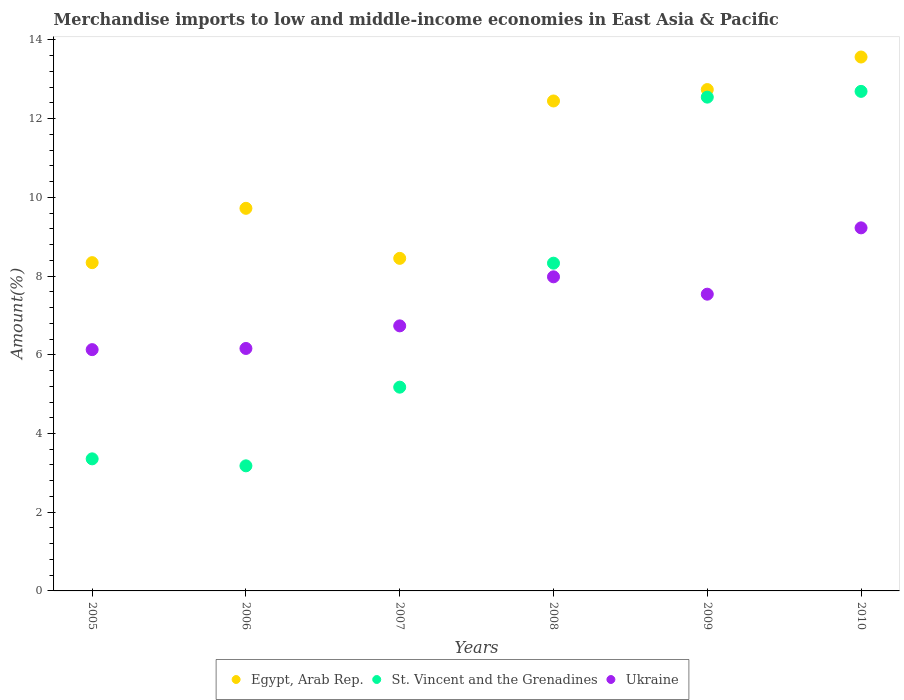How many different coloured dotlines are there?
Your response must be concise. 3. Is the number of dotlines equal to the number of legend labels?
Give a very brief answer. Yes. What is the percentage of amount earned from merchandise imports in Egypt, Arab Rep. in 2005?
Your answer should be very brief. 8.34. Across all years, what is the maximum percentage of amount earned from merchandise imports in Egypt, Arab Rep.?
Offer a terse response. 13.57. Across all years, what is the minimum percentage of amount earned from merchandise imports in Egypt, Arab Rep.?
Provide a short and direct response. 8.34. In which year was the percentage of amount earned from merchandise imports in Egypt, Arab Rep. maximum?
Keep it short and to the point. 2010. What is the total percentage of amount earned from merchandise imports in Egypt, Arab Rep. in the graph?
Your answer should be compact. 65.26. What is the difference between the percentage of amount earned from merchandise imports in Ukraine in 2005 and that in 2006?
Your answer should be very brief. -0.03. What is the difference between the percentage of amount earned from merchandise imports in Egypt, Arab Rep. in 2005 and the percentage of amount earned from merchandise imports in Ukraine in 2008?
Provide a succinct answer. 0.36. What is the average percentage of amount earned from merchandise imports in St. Vincent and the Grenadines per year?
Offer a very short reply. 7.55. In the year 2006, what is the difference between the percentage of amount earned from merchandise imports in Egypt, Arab Rep. and percentage of amount earned from merchandise imports in St. Vincent and the Grenadines?
Offer a terse response. 6.54. What is the ratio of the percentage of amount earned from merchandise imports in Egypt, Arab Rep. in 2006 to that in 2008?
Make the answer very short. 0.78. Is the percentage of amount earned from merchandise imports in Ukraine in 2005 less than that in 2007?
Make the answer very short. Yes. What is the difference between the highest and the second highest percentage of amount earned from merchandise imports in St. Vincent and the Grenadines?
Ensure brevity in your answer.  0.15. What is the difference between the highest and the lowest percentage of amount earned from merchandise imports in Ukraine?
Offer a terse response. 3.09. In how many years, is the percentage of amount earned from merchandise imports in St. Vincent and the Grenadines greater than the average percentage of amount earned from merchandise imports in St. Vincent and the Grenadines taken over all years?
Make the answer very short. 3. Is the sum of the percentage of amount earned from merchandise imports in St. Vincent and the Grenadines in 2005 and 2006 greater than the maximum percentage of amount earned from merchandise imports in Egypt, Arab Rep. across all years?
Ensure brevity in your answer.  No. Is the percentage of amount earned from merchandise imports in Egypt, Arab Rep. strictly less than the percentage of amount earned from merchandise imports in Ukraine over the years?
Your answer should be compact. No. How many years are there in the graph?
Provide a short and direct response. 6. What is the title of the graph?
Provide a succinct answer. Merchandise imports to low and middle-income economies in East Asia & Pacific. What is the label or title of the X-axis?
Give a very brief answer. Years. What is the label or title of the Y-axis?
Keep it short and to the point. Amount(%). What is the Amount(%) of Egypt, Arab Rep. in 2005?
Provide a short and direct response. 8.34. What is the Amount(%) in St. Vincent and the Grenadines in 2005?
Your answer should be very brief. 3.36. What is the Amount(%) in Ukraine in 2005?
Offer a terse response. 6.13. What is the Amount(%) of Egypt, Arab Rep. in 2006?
Provide a short and direct response. 9.72. What is the Amount(%) of St. Vincent and the Grenadines in 2006?
Ensure brevity in your answer.  3.18. What is the Amount(%) in Ukraine in 2006?
Offer a terse response. 6.16. What is the Amount(%) in Egypt, Arab Rep. in 2007?
Ensure brevity in your answer.  8.45. What is the Amount(%) in St. Vincent and the Grenadines in 2007?
Make the answer very short. 5.18. What is the Amount(%) of Ukraine in 2007?
Offer a very short reply. 6.73. What is the Amount(%) of Egypt, Arab Rep. in 2008?
Provide a short and direct response. 12.45. What is the Amount(%) in St. Vincent and the Grenadines in 2008?
Offer a terse response. 8.33. What is the Amount(%) of Ukraine in 2008?
Your response must be concise. 7.98. What is the Amount(%) in Egypt, Arab Rep. in 2009?
Your response must be concise. 12.74. What is the Amount(%) of St. Vincent and the Grenadines in 2009?
Keep it short and to the point. 12.55. What is the Amount(%) in Ukraine in 2009?
Offer a terse response. 7.54. What is the Amount(%) of Egypt, Arab Rep. in 2010?
Offer a very short reply. 13.57. What is the Amount(%) in St. Vincent and the Grenadines in 2010?
Ensure brevity in your answer.  12.69. What is the Amount(%) of Ukraine in 2010?
Your answer should be compact. 9.22. Across all years, what is the maximum Amount(%) of Egypt, Arab Rep.?
Ensure brevity in your answer.  13.57. Across all years, what is the maximum Amount(%) in St. Vincent and the Grenadines?
Keep it short and to the point. 12.69. Across all years, what is the maximum Amount(%) of Ukraine?
Keep it short and to the point. 9.22. Across all years, what is the minimum Amount(%) in Egypt, Arab Rep.?
Keep it short and to the point. 8.34. Across all years, what is the minimum Amount(%) of St. Vincent and the Grenadines?
Provide a short and direct response. 3.18. Across all years, what is the minimum Amount(%) in Ukraine?
Offer a very short reply. 6.13. What is the total Amount(%) in Egypt, Arab Rep. in the graph?
Offer a very short reply. 65.26. What is the total Amount(%) in St. Vincent and the Grenadines in the graph?
Provide a succinct answer. 45.28. What is the total Amount(%) of Ukraine in the graph?
Offer a very short reply. 43.77. What is the difference between the Amount(%) of Egypt, Arab Rep. in 2005 and that in 2006?
Provide a short and direct response. -1.38. What is the difference between the Amount(%) in St. Vincent and the Grenadines in 2005 and that in 2006?
Your response must be concise. 0.18. What is the difference between the Amount(%) in Ukraine in 2005 and that in 2006?
Your response must be concise. -0.03. What is the difference between the Amount(%) in Egypt, Arab Rep. in 2005 and that in 2007?
Offer a terse response. -0.11. What is the difference between the Amount(%) of St. Vincent and the Grenadines in 2005 and that in 2007?
Offer a very short reply. -1.82. What is the difference between the Amount(%) of Ukraine in 2005 and that in 2007?
Offer a terse response. -0.6. What is the difference between the Amount(%) in Egypt, Arab Rep. in 2005 and that in 2008?
Provide a succinct answer. -4.11. What is the difference between the Amount(%) of St. Vincent and the Grenadines in 2005 and that in 2008?
Ensure brevity in your answer.  -4.97. What is the difference between the Amount(%) in Ukraine in 2005 and that in 2008?
Your answer should be very brief. -1.85. What is the difference between the Amount(%) in Egypt, Arab Rep. in 2005 and that in 2009?
Offer a very short reply. -4.4. What is the difference between the Amount(%) in St. Vincent and the Grenadines in 2005 and that in 2009?
Your answer should be very brief. -9.19. What is the difference between the Amount(%) of Ukraine in 2005 and that in 2009?
Your answer should be very brief. -1.41. What is the difference between the Amount(%) of Egypt, Arab Rep. in 2005 and that in 2010?
Make the answer very short. -5.22. What is the difference between the Amount(%) in St. Vincent and the Grenadines in 2005 and that in 2010?
Offer a very short reply. -9.34. What is the difference between the Amount(%) in Ukraine in 2005 and that in 2010?
Your answer should be very brief. -3.09. What is the difference between the Amount(%) in Egypt, Arab Rep. in 2006 and that in 2007?
Ensure brevity in your answer.  1.27. What is the difference between the Amount(%) in St. Vincent and the Grenadines in 2006 and that in 2007?
Keep it short and to the point. -2. What is the difference between the Amount(%) of Ukraine in 2006 and that in 2007?
Your answer should be compact. -0.57. What is the difference between the Amount(%) in Egypt, Arab Rep. in 2006 and that in 2008?
Your answer should be very brief. -2.73. What is the difference between the Amount(%) in St. Vincent and the Grenadines in 2006 and that in 2008?
Ensure brevity in your answer.  -5.15. What is the difference between the Amount(%) of Ukraine in 2006 and that in 2008?
Provide a succinct answer. -1.82. What is the difference between the Amount(%) of Egypt, Arab Rep. in 2006 and that in 2009?
Ensure brevity in your answer.  -3.02. What is the difference between the Amount(%) in St. Vincent and the Grenadines in 2006 and that in 2009?
Your answer should be compact. -9.37. What is the difference between the Amount(%) in Ukraine in 2006 and that in 2009?
Your answer should be compact. -1.38. What is the difference between the Amount(%) in Egypt, Arab Rep. in 2006 and that in 2010?
Your answer should be very brief. -3.84. What is the difference between the Amount(%) in St. Vincent and the Grenadines in 2006 and that in 2010?
Keep it short and to the point. -9.51. What is the difference between the Amount(%) of Ukraine in 2006 and that in 2010?
Keep it short and to the point. -3.06. What is the difference between the Amount(%) in Egypt, Arab Rep. in 2007 and that in 2008?
Your answer should be compact. -4. What is the difference between the Amount(%) of St. Vincent and the Grenadines in 2007 and that in 2008?
Provide a succinct answer. -3.15. What is the difference between the Amount(%) of Ukraine in 2007 and that in 2008?
Offer a terse response. -1.25. What is the difference between the Amount(%) in Egypt, Arab Rep. in 2007 and that in 2009?
Make the answer very short. -4.29. What is the difference between the Amount(%) in St. Vincent and the Grenadines in 2007 and that in 2009?
Your response must be concise. -7.37. What is the difference between the Amount(%) of Ukraine in 2007 and that in 2009?
Make the answer very short. -0.81. What is the difference between the Amount(%) in Egypt, Arab Rep. in 2007 and that in 2010?
Give a very brief answer. -5.12. What is the difference between the Amount(%) in St. Vincent and the Grenadines in 2007 and that in 2010?
Provide a short and direct response. -7.52. What is the difference between the Amount(%) of Ukraine in 2007 and that in 2010?
Keep it short and to the point. -2.49. What is the difference between the Amount(%) of Egypt, Arab Rep. in 2008 and that in 2009?
Offer a very short reply. -0.29. What is the difference between the Amount(%) in St. Vincent and the Grenadines in 2008 and that in 2009?
Offer a very short reply. -4.22. What is the difference between the Amount(%) of Ukraine in 2008 and that in 2009?
Keep it short and to the point. 0.44. What is the difference between the Amount(%) in Egypt, Arab Rep. in 2008 and that in 2010?
Offer a terse response. -1.12. What is the difference between the Amount(%) in St. Vincent and the Grenadines in 2008 and that in 2010?
Ensure brevity in your answer.  -4.37. What is the difference between the Amount(%) of Ukraine in 2008 and that in 2010?
Ensure brevity in your answer.  -1.24. What is the difference between the Amount(%) of Egypt, Arab Rep. in 2009 and that in 2010?
Offer a very short reply. -0.83. What is the difference between the Amount(%) of St. Vincent and the Grenadines in 2009 and that in 2010?
Your answer should be compact. -0.15. What is the difference between the Amount(%) in Ukraine in 2009 and that in 2010?
Your response must be concise. -1.69. What is the difference between the Amount(%) in Egypt, Arab Rep. in 2005 and the Amount(%) in St. Vincent and the Grenadines in 2006?
Provide a succinct answer. 5.16. What is the difference between the Amount(%) of Egypt, Arab Rep. in 2005 and the Amount(%) of Ukraine in 2006?
Provide a short and direct response. 2.18. What is the difference between the Amount(%) of St. Vincent and the Grenadines in 2005 and the Amount(%) of Ukraine in 2006?
Make the answer very short. -2.8. What is the difference between the Amount(%) in Egypt, Arab Rep. in 2005 and the Amount(%) in St. Vincent and the Grenadines in 2007?
Your answer should be compact. 3.16. What is the difference between the Amount(%) of Egypt, Arab Rep. in 2005 and the Amount(%) of Ukraine in 2007?
Your response must be concise. 1.61. What is the difference between the Amount(%) in St. Vincent and the Grenadines in 2005 and the Amount(%) in Ukraine in 2007?
Provide a short and direct response. -3.38. What is the difference between the Amount(%) in Egypt, Arab Rep. in 2005 and the Amount(%) in St. Vincent and the Grenadines in 2008?
Provide a short and direct response. 0.01. What is the difference between the Amount(%) in Egypt, Arab Rep. in 2005 and the Amount(%) in Ukraine in 2008?
Give a very brief answer. 0.36. What is the difference between the Amount(%) in St. Vincent and the Grenadines in 2005 and the Amount(%) in Ukraine in 2008?
Ensure brevity in your answer.  -4.63. What is the difference between the Amount(%) of Egypt, Arab Rep. in 2005 and the Amount(%) of St. Vincent and the Grenadines in 2009?
Make the answer very short. -4.21. What is the difference between the Amount(%) of Egypt, Arab Rep. in 2005 and the Amount(%) of Ukraine in 2009?
Your response must be concise. 0.8. What is the difference between the Amount(%) in St. Vincent and the Grenadines in 2005 and the Amount(%) in Ukraine in 2009?
Your answer should be compact. -4.18. What is the difference between the Amount(%) of Egypt, Arab Rep. in 2005 and the Amount(%) of St. Vincent and the Grenadines in 2010?
Provide a short and direct response. -4.35. What is the difference between the Amount(%) in Egypt, Arab Rep. in 2005 and the Amount(%) in Ukraine in 2010?
Offer a very short reply. -0.88. What is the difference between the Amount(%) of St. Vincent and the Grenadines in 2005 and the Amount(%) of Ukraine in 2010?
Offer a very short reply. -5.87. What is the difference between the Amount(%) in Egypt, Arab Rep. in 2006 and the Amount(%) in St. Vincent and the Grenadines in 2007?
Ensure brevity in your answer.  4.54. What is the difference between the Amount(%) in Egypt, Arab Rep. in 2006 and the Amount(%) in Ukraine in 2007?
Offer a terse response. 2.99. What is the difference between the Amount(%) of St. Vincent and the Grenadines in 2006 and the Amount(%) of Ukraine in 2007?
Keep it short and to the point. -3.56. What is the difference between the Amount(%) in Egypt, Arab Rep. in 2006 and the Amount(%) in St. Vincent and the Grenadines in 2008?
Provide a short and direct response. 1.39. What is the difference between the Amount(%) in Egypt, Arab Rep. in 2006 and the Amount(%) in Ukraine in 2008?
Offer a terse response. 1.74. What is the difference between the Amount(%) of St. Vincent and the Grenadines in 2006 and the Amount(%) of Ukraine in 2008?
Keep it short and to the point. -4.8. What is the difference between the Amount(%) of Egypt, Arab Rep. in 2006 and the Amount(%) of St. Vincent and the Grenadines in 2009?
Offer a very short reply. -2.82. What is the difference between the Amount(%) of Egypt, Arab Rep. in 2006 and the Amount(%) of Ukraine in 2009?
Provide a short and direct response. 2.18. What is the difference between the Amount(%) in St. Vincent and the Grenadines in 2006 and the Amount(%) in Ukraine in 2009?
Your response must be concise. -4.36. What is the difference between the Amount(%) of Egypt, Arab Rep. in 2006 and the Amount(%) of St. Vincent and the Grenadines in 2010?
Your response must be concise. -2.97. What is the difference between the Amount(%) of Egypt, Arab Rep. in 2006 and the Amount(%) of Ukraine in 2010?
Keep it short and to the point. 0.5. What is the difference between the Amount(%) of St. Vincent and the Grenadines in 2006 and the Amount(%) of Ukraine in 2010?
Offer a very short reply. -6.05. What is the difference between the Amount(%) of Egypt, Arab Rep. in 2007 and the Amount(%) of St. Vincent and the Grenadines in 2008?
Keep it short and to the point. 0.12. What is the difference between the Amount(%) of Egypt, Arab Rep. in 2007 and the Amount(%) of Ukraine in 2008?
Your response must be concise. 0.47. What is the difference between the Amount(%) of St. Vincent and the Grenadines in 2007 and the Amount(%) of Ukraine in 2008?
Keep it short and to the point. -2.8. What is the difference between the Amount(%) of Egypt, Arab Rep. in 2007 and the Amount(%) of St. Vincent and the Grenadines in 2009?
Ensure brevity in your answer.  -4.1. What is the difference between the Amount(%) of Egypt, Arab Rep. in 2007 and the Amount(%) of Ukraine in 2009?
Your answer should be compact. 0.91. What is the difference between the Amount(%) in St. Vincent and the Grenadines in 2007 and the Amount(%) in Ukraine in 2009?
Your answer should be very brief. -2.36. What is the difference between the Amount(%) in Egypt, Arab Rep. in 2007 and the Amount(%) in St. Vincent and the Grenadines in 2010?
Your answer should be compact. -4.24. What is the difference between the Amount(%) of Egypt, Arab Rep. in 2007 and the Amount(%) of Ukraine in 2010?
Ensure brevity in your answer.  -0.78. What is the difference between the Amount(%) of St. Vincent and the Grenadines in 2007 and the Amount(%) of Ukraine in 2010?
Offer a very short reply. -4.05. What is the difference between the Amount(%) in Egypt, Arab Rep. in 2008 and the Amount(%) in St. Vincent and the Grenadines in 2009?
Your answer should be very brief. -0.1. What is the difference between the Amount(%) in Egypt, Arab Rep. in 2008 and the Amount(%) in Ukraine in 2009?
Your answer should be compact. 4.91. What is the difference between the Amount(%) in St. Vincent and the Grenadines in 2008 and the Amount(%) in Ukraine in 2009?
Your answer should be compact. 0.79. What is the difference between the Amount(%) in Egypt, Arab Rep. in 2008 and the Amount(%) in St. Vincent and the Grenadines in 2010?
Provide a short and direct response. -0.24. What is the difference between the Amount(%) in Egypt, Arab Rep. in 2008 and the Amount(%) in Ukraine in 2010?
Keep it short and to the point. 3.22. What is the difference between the Amount(%) of St. Vincent and the Grenadines in 2008 and the Amount(%) of Ukraine in 2010?
Make the answer very short. -0.9. What is the difference between the Amount(%) of Egypt, Arab Rep. in 2009 and the Amount(%) of St. Vincent and the Grenadines in 2010?
Your answer should be very brief. 0.05. What is the difference between the Amount(%) in Egypt, Arab Rep. in 2009 and the Amount(%) in Ukraine in 2010?
Make the answer very short. 3.51. What is the difference between the Amount(%) of St. Vincent and the Grenadines in 2009 and the Amount(%) of Ukraine in 2010?
Your response must be concise. 3.32. What is the average Amount(%) in Egypt, Arab Rep. per year?
Ensure brevity in your answer.  10.88. What is the average Amount(%) in St. Vincent and the Grenadines per year?
Your answer should be compact. 7.55. What is the average Amount(%) in Ukraine per year?
Offer a terse response. 7.29. In the year 2005, what is the difference between the Amount(%) of Egypt, Arab Rep. and Amount(%) of St. Vincent and the Grenadines?
Offer a very short reply. 4.99. In the year 2005, what is the difference between the Amount(%) of Egypt, Arab Rep. and Amount(%) of Ukraine?
Give a very brief answer. 2.21. In the year 2005, what is the difference between the Amount(%) of St. Vincent and the Grenadines and Amount(%) of Ukraine?
Make the answer very short. -2.78. In the year 2006, what is the difference between the Amount(%) in Egypt, Arab Rep. and Amount(%) in St. Vincent and the Grenadines?
Your answer should be very brief. 6.54. In the year 2006, what is the difference between the Amount(%) in Egypt, Arab Rep. and Amount(%) in Ukraine?
Provide a short and direct response. 3.56. In the year 2006, what is the difference between the Amount(%) in St. Vincent and the Grenadines and Amount(%) in Ukraine?
Give a very brief answer. -2.98. In the year 2007, what is the difference between the Amount(%) in Egypt, Arab Rep. and Amount(%) in St. Vincent and the Grenadines?
Offer a terse response. 3.27. In the year 2007, what is the difference between the Amount(%) of Egypt, Arab Rep. and Amount(%) of Ukraine?
Offer a terse response. 1.72. In the year 2007, what is the difference between the Amount(%) of St. Vincent and the Grenadines and Amount(%) of Ukraine?
Offer a terse response. -1.56. In the year 2008, what is the difference between the Amount(%) in Egypt, Arab Rep. and Amount(%) in St. Vincent and the Grenadines?
Your answer should be very brief. 4.12. In the year 2008, what is the difference between the Amount(%) of Egypt, Arab Rep. and Amount(%) of Ukraine?
Offer a very short reply. 4.47. In the year 2008, what is the difference between the Amount(%) of St. Vincent and the Grenadines and Amount(%) of Ukraine?
Your answer should be compact. 0.35. In the year 2009, what is the difference between the Amount(%) in Egypt, Arab Rep. and Amount(%) in St. Vincent and the Grenadines?
Give a very brief answer. 0.19. In the year 2009, what is the difference between the Amount(%) in Egypt, Arab Rep. and Amount(%) in Ukraine?
Your answer should be compact. 5.2. In the year 2009, what is the difference between the Amount(%) of St. Vincent and the Grenadines and Amount(%) of Ukraine?
Provide a short and direct response. 5.01. In the year 2010, what is the difference between the Amount(%) of Egypt, Arab Rep. and Amount(%) of St. Vincent and the Grenadines?
Provide a short and direct response. 0.87. In the year 2010, what is the difference between the Amount(%) of Egypt, Arab Rep. and Amount(%) of Ukraine?
Ensure brevity in your answer.  4.34. In the year 2010, what is the difference between the Amount(%) of St. Vincent and the Grenadines and Amount(%) of Ukraine?
Offer a very short reply. 3.47. What is the ratio of the Amount(%) of Egypt, Arab Rep. in 2005 to that in 2006?
Give a very brief answer. 0.86. What is the ratio of the Amount(%) of St. Vincent and the Grenadines in 2005 to that in 2006?
Your answer should be compact. 1.06. What is the ratio of the Amount(%) in Ukraine in 2005 to that in 2006?
Offer a very short reply. 1. What is the ratio of the Amount(%) in Egypt, Arab Rep. in 2005 to that in 2007?
Your answer should be very brief. 0.99. What is the ratio of the Amount(%) of St. Vincent and the Grenadines in 2005 to that in 2007?
Offer a terse response. 0.65. What is the ratio of the Amount(%) of Ukraine in 2005 to that in 2007?
Give a very brief answer. 0.91. What is the ratio of the Amount(%) of Egypt, Arab Rep. in 2005 to that in 2008?
Give a very brief answer. 0.67. What is the ratio of the Amount(%) in St. Vincent and the Grenadines in 2005 to that in 2008?
Ensure brevity in your answer.  0.4. What is the ratio of the Amount(%) in Ukraine in 2005 to that in 2008?
Give a very brief answer. 0.77. What is the ratio of the Amount(%) in Egypt, Arab Rep. in 2005 to that in 2009?
Give a very brief answer. 0.65. What is the ratio of the Amount(%) of St. Vincent and the Grenadines in 2005 to that in 2009?
Ensure brevity in your answer.  0.27. What is the ratio of the Amount(%) of Ukraine in 2005 to that in 2009?
Your answer should be very brief. 0.81. What is the ratio of the Amount(%) in Egypt, Arab Rep. in 2005 to that in 2010?
Give a very brief answer. 0.61. What is the ratio of the Amount(%) of St. Vincent and the Grenadines in 2005 to that in 2010?
Keep it short and to the point. 0.26. What is the ratio of the Amount(%) in Ukraine in 2005 to that in 2010?
Your response must be concise. 0.66. What is the ratio of the Amount(%) of Egypt, Arab Rep. in 2006 to that in 2007?
Provide a short and direct response. 1.15. What is the ratio of the Amount(%) in St. Vincent and the Grenadines in 2006 to that in 2007?
Your answer should be very brief. 0.61. What is the ratio of the Amount(%) in Ukraine in 2006 to that in 2007?
Your response must be concise. 0.91. What is the ratio of the Amount(%) of Egypt, Arab Rep. in 2006 to that in 2008?
Keep it short and to the point. 0.78. What is the ratio of the Amount(%) of St. Vincent and the Grenadines in 2006 to that in 2008?
Offer a very short reply. 0.38. What is the ratio of the Amount(%) of Ukraine in 2006 to that in 2008?
Your answer should be compact. 0.77. What is the ratio of the Amount(%) of Egypt, Arab Rep. in 2006 to that in 2009?
Your answer should be compact. 0.76. What is the ratio of the Amount(%) in St. Vincent and the Grenadines in 2006 to that in 2009?
Your answer should be very brief. 0.25. What is the ratio of the Amount(%) of Ukraine in 2006 to that in 2009?
Offer a very short reply. 0.82. What is the ratio of the Amount(%) in Egypt, Arab Rep. in 2006 to that in 2010?
Your response must be concise. 0.72. What is the ratio of the Amount(%) in St. Vincent and the Grenadines in 2006 to that in 2010?
Keep it short and to the point. 0.25. What is the ratio of the Amount(%) of Ukraine in 2006 to that in 2010?
Provide a succinct answer. 0.67. What is the ratio of the Amount(%) of Egypt, Arab Rep. in 2007 to that in 2008?
Offer a very short reply. 0.68. What is the ratio of the Amount(%) in St. Vincent and the Grenadines in 2007 to that in 2008?
Keep it short and to the point. 0.62. What is the ratio of the Amount(%) in Ukraine in 2007 to that in 2008?
Your answer should be compact. 0.84. What is the ratio of the Amount(%) in Egypt, Arab Rep. in 2007 to that in 2009?
Provide a succinct answer. 0.66. What is the ratio of the Amount(%) in St. Vincent and the Grenadines in 2007 to that in 2009?
Provide a short and direct response. 0.41. What is the ratio of the Amount(%) of Ukraine in 2007 to that in 2009?
Make the answer very short. 0.89. What is the ratio of the Amount(%) of Egypt, Arab Rep. in 2007 to that in 2010?
Your answer should be compact. 0.62. What is the ratio of the Amount(%) in St. Vincent and the Grenadines in 2007 to that in 2010?
Offer a terse response. 0.41. What is the ratio of the Amount(%) of Ukraine in 2007 to that in 2010?
Your answer should be very brief. 0.73. What is the ratio of the Amount(%) of Egypt, Arab Rep. in 2008 to that in 2009?
Provide a short and direct response. 0.98. What is the ratio of the Amount(%) in St. Vincent and the Grenadines in 2008 to that in 2009?
Your response must be concise. 0.66. What is the ratio of the Amount(%) in Ukraine in 2008 to that in 2009?
Offer a very short reply. 1.06. What is the ratio of the Amount(%) of Egypt, Arab Rep. in 2008 to that in 2010?
Keep it short and to the point. 0.92. What is the ratio of the Amount(%) of St. Vincent and the Grenadines in 2008 to that in 2010?
Ensure brevity in your answer.  0.66. What is the ratio of the Amount(%) in Ukraine in 2008 to that in 2010?
Ensure brevity in your answer.  0.87. What is the ratio of the Amount(%) of Egypt, Arab Rep. in 2009 to that in 2010?
Your answer should be compact. 0.94. What is the ratio of the Amount(%) of Ukraine in 2009 to that in 2010?
Provide a short and direct response. 0.82. What is the difference between the highest and the second highest Amount(%) in Egypt, Arab Rep.?
Your answer should be compact. 0.83. What is the difference between the highest and the second highest Amount(%) of St. Vincent and the Grenadines?
Your response must be concise. 0.15. What is the difference between the highest and the second highest Amount(%) in Ukraine?
Provide a succinct answer. 1.24. What is the difference between the highest and the lowest Amount(%) of Egypt, Arab Rep.?
Your answer should be compact. 5.22. What is the difference between the highest and the lowest Amount(%) of St. Vincent and the Grenadines?
Keep it short and to the point. 9.51. What is the difference between the highest and the lowest Amount(%) of Ukraine?
Your answer should be very brief. 3.09. 